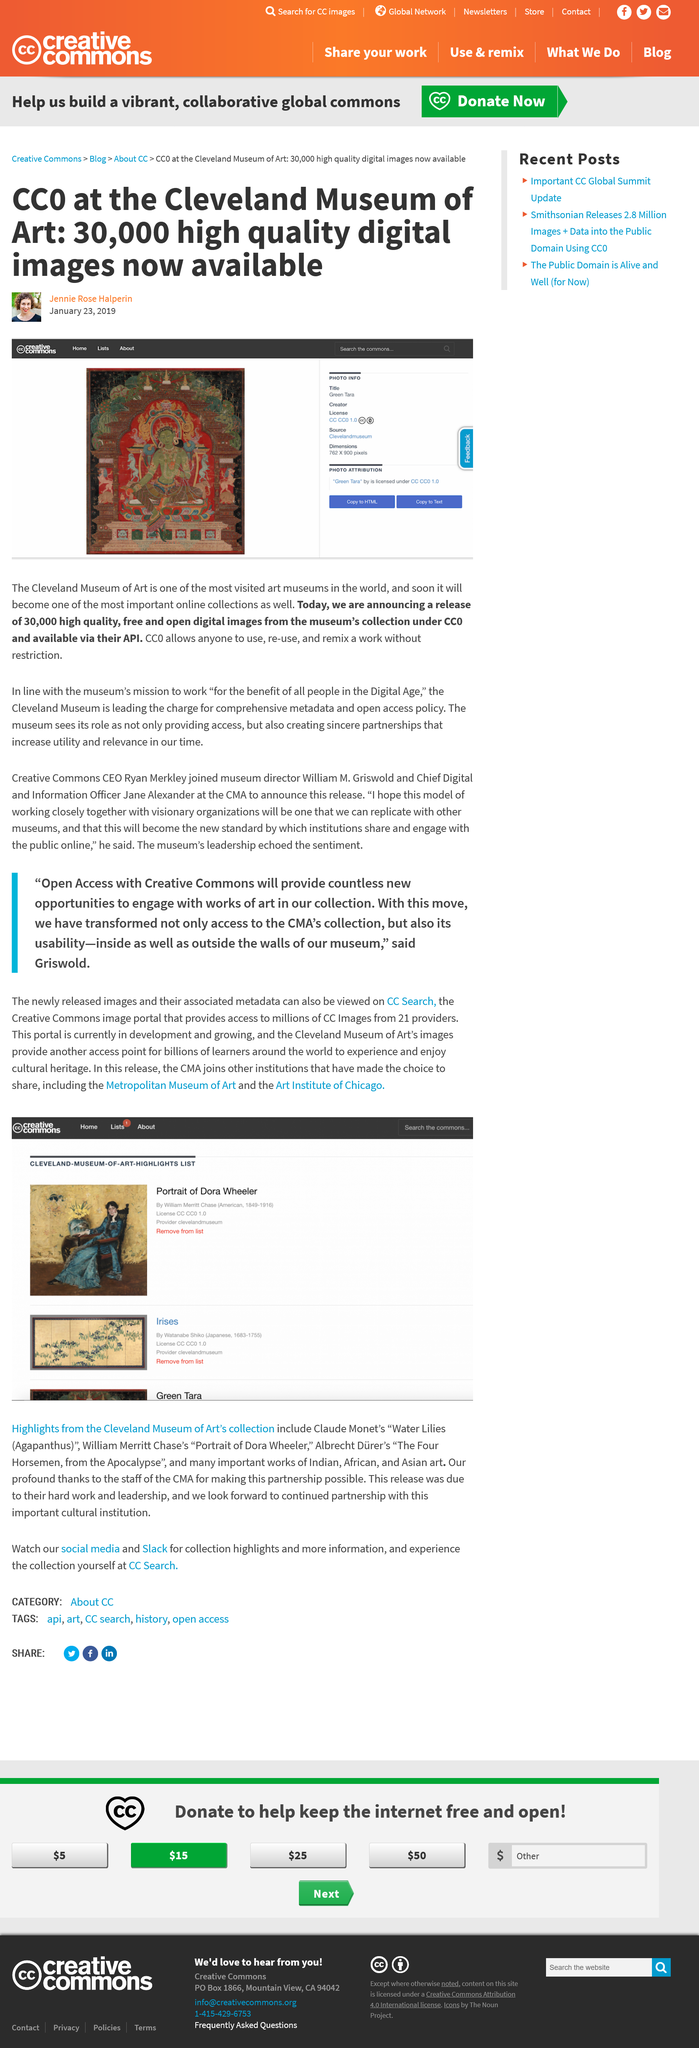Draw attention to some important aspects in this diagram. The main image displayed is titled "Green Tara. The Cleveland Museum of Art is proud to announce the release of 30,000 high-quality, free and open images from its extensive collection. CC0 is a legal tool that allows individuals to release their creative works into the public domain by waiving all rights, including copyright. 